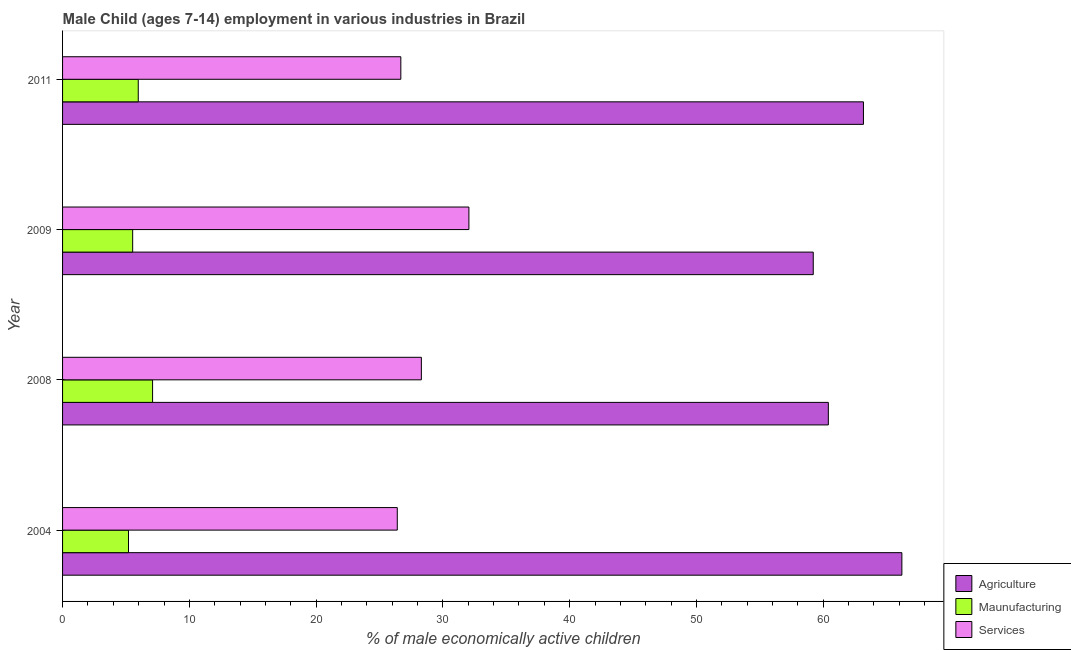How many different coloured bars are there?
Give a very brief answer. 3. Are the number of bars on each tick of the Y-axis equal?
Ensure brevity in your answer.  Yes. How many bars are there on the 2nd tick from the bottom?
Your answer should be compact. 3. What is the label of the 4th group of bars from the top?
Provide a short and direct response. 2004. In how many cases, is the number of bars for a given year not equal to the number of legend labels?
Your answer should be compact. 0. Across all years, what is the maximum percentage of economically active children in agriculture?
Give a very brief answer. 66.2. Across all years, what is the minimum percentage of economically active children in agriculture?
Your answer should be very brief. 59.21. In which year was the percentage of economically active children in manufacturing minimum?
Ensure brevity in your answer.  2004. What is the total percentage of economically active children in manufacturing in the graph?
Ensure brevity in your answer.  23.8. What is the difference between the percentage of economically active children in services in 2004 and that in 2011?
Provide a succinct answer. -0.28. What is the difference between the percentage of economically active children in services in 2008 and the percentage of economically active children in manufacturing in 2011?
Offer a terse response. 22.33. What is the average percentage of economically active children in agriculture per year?
Offer a terse response. 62.24. In the year 2008, what is the difference between the percentage of economically active children in services and percentage of economically active children in agriculture?
Provide a succinct answer. -32.1. What is the ratio of the percentage of economically active children in services in 2004 to that in 2011?
Provide a short and direct response. 0.99. Is the difference between the percentage of economically active children in agriculture in 2008 and 2009 greater than the difference between the percentage of economically active children in services in 2008 and 2009?
Your response must be concise. Yes. What is the difference between the highest and the second highest percentage of economically active children in services?
Your response must be concise. 3.75. In how many years, is the percentage of economically active children in services greater than the average percentage of economically active children in services taken over all years?
Provide a succinct answer. 1. What does the 3rd bar from the top in 2009 represents?
Provide a succinct answer. Agriculture. What does the 2nd bar from the bottom in 2011 represents?
Provide a succinct answer. Maunufacturing. Is it the case that in every year, the sum of the percentage of economically active children in agriculture and percentage of economically active children in manufacturing is greater than the percentage of economically active children in services?
Provide a succinct answer. Yes. What is the difference between two consecutive major ticks on the X-axis?
Provide a short and direct response. 10. Does the graph contain grids?
Ensure brevity in your answer.  No. Where does the legend appear in the graph?
Your answer should be very brief. Bottom right. What is the title of the graph?
Ensure brevity in your answer.  Male Child (ages 7-14) employment in various industries in Brazil. Does "Agricultural raw materials" appear as one of the legend labels in the graph?
Provide a succinct answer. No. What is the label or title of the X-axis?
Ensure brevity in your answer.  % of male economically active children. What is the % of male economically active children in Agriculture in 2004?
Your answer should be very brief. 66.2. What is the % of male economically active children of Services in 2004?
Offer a very short reply. 26.4. What is the % of male economically active children in Agriculture in 2008?
Your answer should be very brief. 60.4. What is the % of male economically active children in Services in 2008?
Your answer should be compact. 28.3. What is the % of male economically active children in Agriculture in 2009?
Provide a short and direct response. 59.21. What is the % of male economically active children in Maunufacturing in 2009?
Your answer should be very brief. 5.53. What is the % of male economically active children of Services in 2009?
Provide a short and direct response. 32.05. What is the % of male economically active children of Agriculture in 2011?
Offer a terse response. 63.17. What is the % of male economically active children in Maunufacturing in 2011?
Your answer should be compact. 5.97. What is the % of male economically active children in Services in 2011?
Your answer should be very brief. 26.68. Across all years, what is the maximum % of male economically active children in Agriculture?
Provide a short and direct response. 66.2. Across all years, what is the maximum % of male economically active children in Maunufacturing?
Your answer should be compact. 7.1. Across all years, what is the maximum % of male economically active children of Services?
Provide a short and direct response. 32.05. Across all years, what is the minimum % of male economically active children in Agriculture?
Give a very brief answer. 59.21. Across all years, what is the minimum % of male economically active children in Maunufacturing?
Your answer should be compact. 5.2. Across all years, what is the minimum % of male economically active children of Services?
Give a very brief answer. 26.4. What is the total % of male economically active children in Agriculture in the graph?
Give a very brief answer. 248.98. What is the total % of male economically active children in Maunufacturing in the graph?
Provide a short and direct response. 23.8. What is the total % of male economically active children in Services in the graph?
Keep it short and to the point. 113.43. What is the difference between the % of male economically active children in Agriculture in 2004 and that in 2008?
Provide a succinct answer. 5.8. What is the difference between the % of male economically active children in Services in 2004 and that in 2008?
Give a very brief answer. -1.9. What is the difference between the % of male economically active children of Agriculture in 2004 and that in 2009?
Provide a succinct answer. 6.99. What is the difference between the % of male economically active children of Maunufacturing in 2004 and that in 2009?
Your answer should be compact. -0.33. What is the difference between the % of male economically active children in Services in 2004 and that in 2009?
Make the answer very short. -5.65. What is the difference between the % of male economically active children of Agriculture in 2004 and that in 2011?
Ensure brevity in your answer.  3.03. What is the difference between the % of male economically active children in Maunufacturing in 2004 and that in 2011?
Make the answer very short. -0.77. What is the difference between the % of male economically active children of Services in 2004 and that in 2011?
Offer a very short reply. -0.28. What is the difference between the % of male economically active children of Agriculture in 2008 and that in 2009?
Your answer should be very brief. 1.19. What is the difference between the % of male economically active children in Maunufacturing in 2008 and that in 2009?
Offer a very short reply. 1.57. What is the difference between the % of male economically active children of Services in 2008 and that in 2009?
Keep it short and to the point. -3.75. What is the difference between the % of male economically active children of Agriculture in 2008 and that in 2011?
Your answer should be compact. -2.77. What is the difference between the % of male economically active children of Maunufacturing in 2008 and that in 2011?
Keep it short and to the point. 1.13. What is the difference between the % of male economically active children in Services in 2008 and that in 2011?
Provide a succinct answer. 1.62. What is the difference between the % of male economically active children in Agriculture in 2009 and that in 2011?
Make the answer very short. -3.96. What is the difference between the % of male economically active children in Maunufacturing in 2009 and that in 2011?
Offer a very short reply. -0.44. What is the difference between the % of male economically active children in Services in 2009 and that in 2011?
Keep it short and to the point. 5.37. What is the difference between the % of male economically active children of Agriculture in 2004 and the % of male economically active children of Maunufacturing in 2008?
Make the answer very short. 59.1. What is the difference between the % of male economically active children of Agriculture in 2004 and the % of male economically active children of Services in 2008?
Your answer should be compact. 37.9. What is the difference between the % of male economically active children in Maunufacturing in 2004 and the % of male economically active children in Services in 2008?
Offer a terse response. -23.1. What is the difference between the % of male economically active children of Agriculture in 2004 and the % of male economically active children of Maunufacturing in 2009?
Keep it short and to the point. 60.67. What is the difference between the % of male economically active children in Agriculture in 2004 and the % of male economically active children in Services in 2009?
Offer a very short reply. 34.15. What is the difference between the % of male economically active children of Maunufacturing in 2004 and the % of male economically active children of Services in 2009?
Ensure brevity in your answer.  -26.85. What is the difference between the % of male economically active children in Agriculture in 2004 and the % of male economically active children in Maunufacturing in 2011?
Keep it short and to the point. 60.23. What is the difference between the % of male economically active children of Agriculture in 2004 and the % of male economically active children of Services in 2011?
Your answer should be compact. 39.52. What is the difference between the % of male economically active children of Maunufacturing in 2004 and the % of male economically active children of Services in 2011?
Give a very brief answer. -21.48. What is the difference between the % of male economically active children in Agriculture in 2008 and the % of male economically active children in Maunufacturing in 2009?
Your answer should be compact. 54.87. What is the difference between the % of male economically active children in Agriculture in 2008 and the % of male economically active children in Services in 2009?
Make the answer very short. 28.35. What is the difference between the % of male economically active children in Maunufacturing in 2008 and the % of male economically active children in Services in 2009?
Give a very brief answer. -24.95. What is the difference between the % of male economically active children in Agriculture in 2008 and the % of male economically active children in Maunufacturing in 2011?
Provide a short and direct response. 54.43. What is the difference between the % of male economically active children of Agriculture in 2008 and the % of male economically active children of Services in 2011?
Ensure brevity in your answer.  33.72. What is the difference between the % of male economically active children in Maunufacturing in 2008 and the % of male economically active children in Services in 2011?
Offer a very short reply. -19.58. What is the difference between the % of male economically active children in Agriculture in 2009 and the % of male economically active children in Maunufacturing in 2011?
Give a very brief answer. 53.24. What is the difference between the % of male economically active children of Agriculture in 2009 and the % of male economically active children of Services in 2011?
Give a very brief answer. 32.53. What is the difference between the % of male economically active children of Maunufacturing in 2009 and the % of male economically active children of Services in 2011?
Keep it short and to the point. -21.15. What is the average % of male economically active children in Agriculture per year?
Your answer should be very brief. 62.24. What is the average % of male economically active children of Maunufacturing per year?
Offer a very short reply. 5.95. What is the average % of male economically active children in Services per year?
Provide a short and direct response. 28.36. In the year 2004, what is the difference between the % of male economically active children of Agriculture and % of male economically active children of Maunufacturing?
Provide a succinct answer. 61. In the year 2004, what is the difference between the % of male economically active children of Agriculture and % of male economically active children of Services?
Your answer should be very brief. 39.8. In the year 2004, what is the difference between the % of male economically active children in Maunufacturing and % of male economically active children in Services?
Your response must be concise. -21.2. In the year 2008, what is the difference between the % of male economically active children in Agriculture and % of male economically active children in Maunufacturing?
Offer a very short reply. 53.3. In the year 2008, what is the difference between the % of male economically active children of Agriculture and % of male economically active children of Services?
Offer a terse response. 32.1. In the year 2008, what is the difference between the % of male economically active children of Maunufacturing and % of male economically active children of Services?
Give a very brief answer. -21.2. In the year 2009, what is the difference between the % of male economically active children in Agriculture and % of male economically active children in Maunufacturing?
Provide a short and direct response. 53.68. In the year 2009, what is the difference between the % of male economically active children in Agriculture and % of male economically active children in Services?
Your response must be concise. 27.16. In the year 2009, what is the difference between the % of male economically active children of Maunufacturing and % of male economically active children of Services?
Provide a short and direct response. -26.52. In the year 2011, what is the difference between the % of male economically active children in Agriculture and % of male economically active children in Maunufacturing?
Offer a very short reply. 57.2. In the year 2011, what is the difference between the % of male economically active children in Agriculture and % of male economically active children in Services?
Provide a short and direct response. 36.49. In the year 2011, what is the difference between the % of male economically active children of Maunufacturing and % of male economically active children of Services?
Offer a terse response. -20.71. What is the ratio of the % of male economically active children of Agriculture in 2004 to that in 2008?
Give a very brief answer. 1.1. What is the ratio of the % of male economically active children of Maunufacturing in 2004 to that in 2008?
Keep it short and to the point. 0.73. What is the ratio of the % of male economically active children in Services in 2004 to that in 2008?
Provide a short and direct response. 0.93. What is the ratio of the % of male economically active children in Agriculture in 2004 to that in 2009?
Provide a short and direct response. 1.12. What is the ratio of the % of male economically active children of Maunufacturing in 2004 to that in 2009?
Offer a very short reply. 0.94. What is the ratio of the % of male economically active children in Services in 2004 to that in 2009?
Provide a short and direct response. 0.82. What is the ratio of the % of male economically active children of Agriculture in 2004 to that in 2011?
Give a very brief answer. 1.05. What is the ratio of the % of male economically active children in Maunufacturing in 2004 to that in 2011?
Offer a very short reply. 0.87. What is the ratio of the % of male economically active children in Agriculture in 2008 to that in 2009?
Provide a short and direct response. 1.02. What is the ratio of the % of male economically active children of Maunufacturing in 2008 to that in 2009?
Offer a very short reply. 1.28. What is the ratio of the % of male economically active children of Services in 2008 to that in 2009?
Provide a succinct answer. 0.88. What is the ratio of the % of male economically active children in Agriculture in 2008 to that in 2011?
Your answer should be very brief. 0.96. What is the ratio of the % of male economically active children in Maunufacturing in 2008 to that in 2011?
Your answer should be very brief. 1.19. What is the ratio of the % of male economically active children of Services in 2008 to that in 2011?
Offer a very short reply. 1.06. What is the ratio of the % of male economically active children of Agriculture in 2009 to that in 2011?
Keep it short and to the point. 0.94. What is the ratio of the % of male economically active children in Maunufacturing in 2009 to that in 2011?
Your answer should be compact. 0.93. What is the ratio of the % of male economically active children of Services in 2009 to that in 2011?
Keep it short and to the point. 1.2. What is the difference between the highest and the second highest % of male economically active children of Agriculture?
Provide a succinct answer. 3.03. What is the difference between the highest and the second highest % of male economically active children of Maunufacturing?
Offer a terse response. 1.13. What is the difference between the highest and the second highest % of male economically active children in Services?
Offer a very short reply. 3.75. What is the difference between the highest and the lowest % of male economically active children of Agriculture?
Make the answer very short. 6.99. What is the difference between the highest and the lowest % of male economically active children of Maunufacturing?
Keep it short and to the point. 1.9. What is the difference between the highest and the lowest % of male economically active children of Services?
Ensure brevity in your answer.  5.65. 